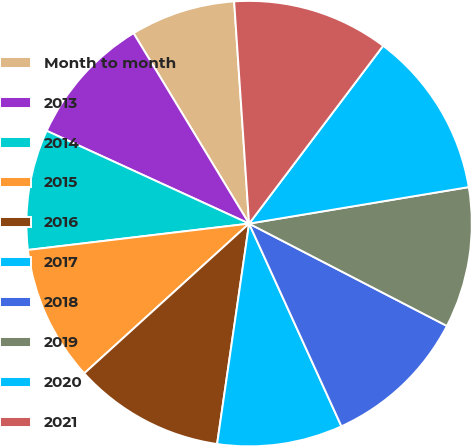Convert chart. <chart><loc_0><loc_0><loc_500><loc_500><pie_chart><fcel>Month to month<fcel>2013<fcel>2014<fcel>2015<fcel>2016<fcel>2017<fcel>2018<fcel>2019<fcel>2020<fcel>2021<nl><fcel>7.61%<fcel>9.48%<fcel>8.73%<fcel>9.85%<fcel>10.97%<fcel>9.1%<fcel>10.6%<fcel>10.22%<fcel>12.1%<fcel>11.35%<nl></chart> 